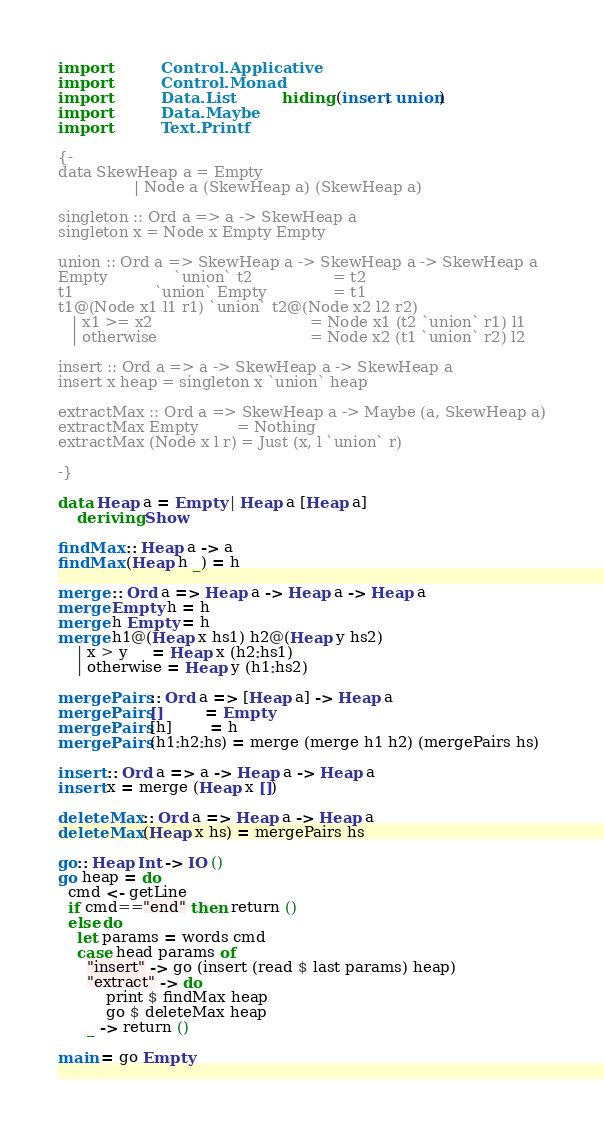<code> <loc_0><loc_0><loc_500><loc_500><_Haskell_>import           Control.Applicative
import           Control.Monad
import           Data.List           hiding (insert, union)
import           Data.Maybe
import           Text.Printf

{-
data SkewHeap a = Empty
                | Node a (SkewHeap a) (SkewHeap a)

singleton :: Ord a => a -> SkewHeap a
singleton x = Node x Empty Empty

union :: Ord a => SkewHeap a -> SkewHeap a -> SkewHeap a
Empty              `union` t2                 = t2
t1                 `union` Empty              = t1
t1@(Node x1 l1 r1) `union` t2@(Node x2 l2 r2)
   | x1 >= x2                                 = Node x1 (t2 `union` r1) l1
   | otherwise                                = Node x2 (t1 `union` r2) l2

insert :: Ord a => a -> SkewHeap a -> SkewHeap a
insert x heap = singleton x `union` heap

extractMax :: Ord a => SkewHeap a -> Maybe (a, SkewHeap a)
extractMax Empty        = Nothing
extractMax (Node x l r) = Just (x, l `union` r)

-}

data Heap a = Empty | Heap a [Heap a]
    deriving Show

findMax :: Heap a -> a
findMax (Heap h _) = h

merge :: Ord a => Heap a -> Heap a -> Heap a
merge Empty h = h
merge h Empty = h
merge h1@(Heap x hs1) h2@(Heap y hs2)
    | x > y     = Heap x (h2:hs1)
    | otherwise = Heap y (h1:hs2)

mergePairs :: Ord a => [Heap a] -> Heap a
mergePairs []         = Empty
mergePairs [h]        = h
mergePairs (h1:h2:hs) = merge (merge h1 h2) (mergePairs hs)

insert :: Ord a => a -> Heap a -> Heap a
insert x = merge (Heap x [])

deleteMax :: Ord a => Heap a -> Heap a
deleteMax (Heap x hs) = mergePairs hs

go:: Heap Int -> IO ()
go heap = do
  cmd <- getLine
  if cmd=="end" then return ()
  else do
    let params = words cmd
    case head params of
      "insert" -> go (insert (read $ last params) heap)
      "extract" -> do
          print $ findMax heap
          go $ deleteMax heap
      _ -> return ()

main = go Empty

</code> 